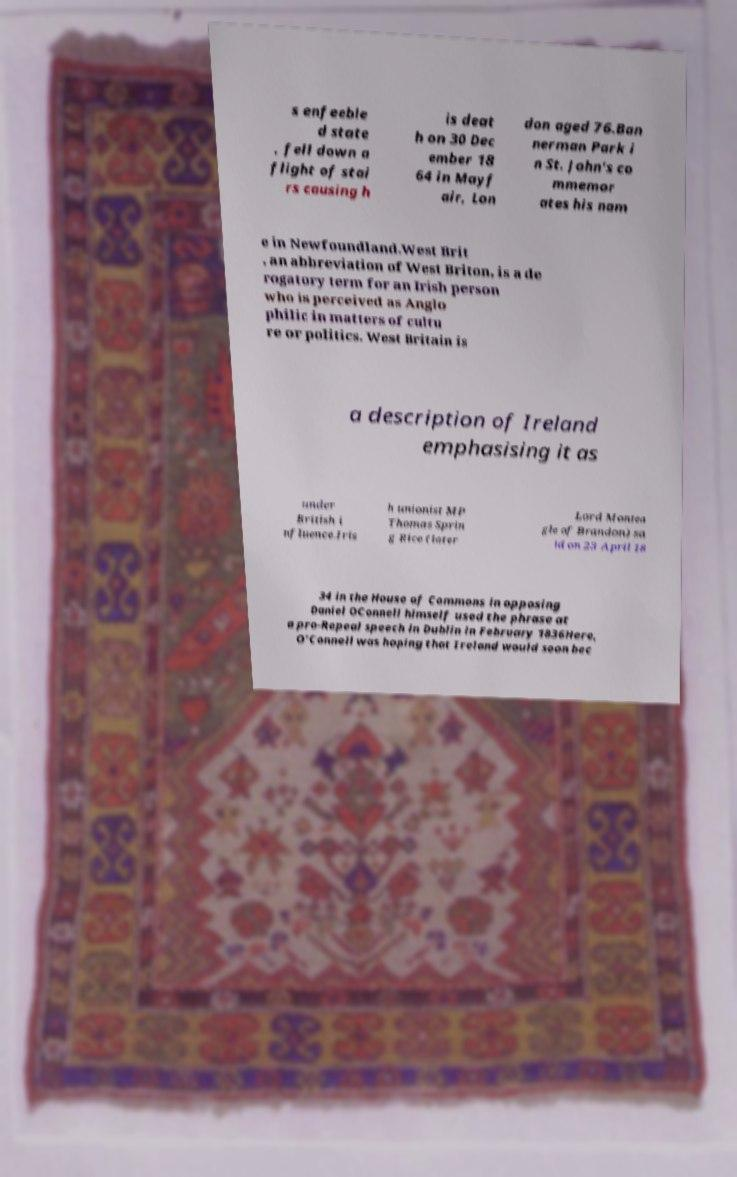Could you extract and type out the text from this image? s enfeeble d state , fell down a flight of stai rs causing h is deat h on 30 Dec ember 18 64 in Mayf air, Lon don aged 76.Ban nerman Park i n St. John's co mmemor ates his nam e in Newfoundland.West Brit , an abbreviation of West Briton, is a de rogatory term for an Irish person who is perceived as Anglo philic in matters of cultu re or politics. West Britain is a description of Ireland emphasising it as under British i nfluence.Iris h unionist MP Thomas Sprin g Rice (later Lord Montea gle of Brandon) sa id on 23 April 18 34 in the House of Commons in opposing Daniel OConnell himself used the phrase at a pro-Repeal speech in Dublin in February 1836Here, O'Connell was hoping that Ireland would soon bec 